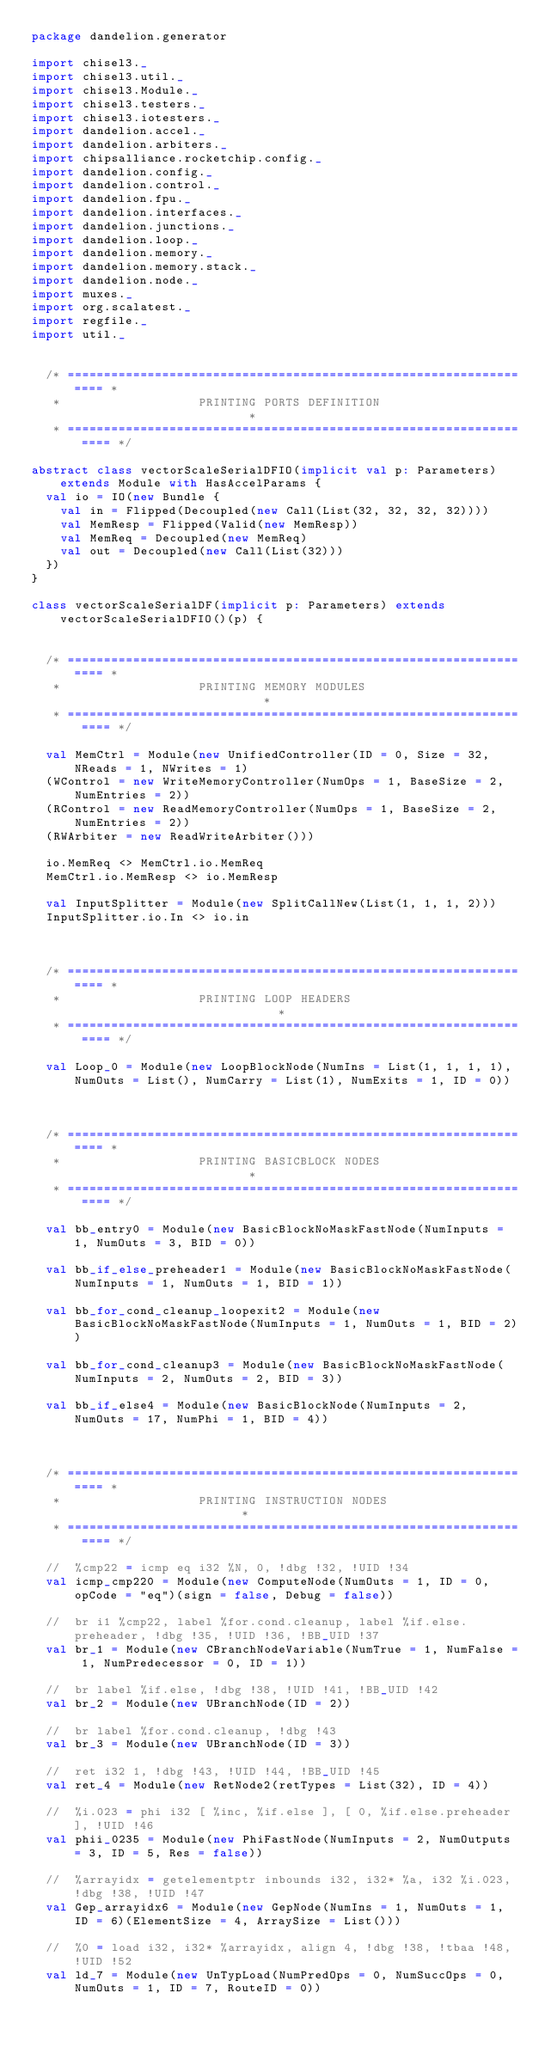<code> <loc_0><loc_0><loc_500><loc_500><_Scala_>package dandelion.generator

import chisel3._
import chisel3.util._
import chisel3.Module._
import chisel3.testers._
import chisel3.iotesters._
import dandelion.accel._
import dandelion.arbiters._
import chipsalliance.rocketchip.config._
import dandelion.config._
import dandelion.control._
import dandelion.fpu._
import dandelion.interfaces._
import dandelion.junctions._
import dandelion.loop._
import dandelion.memory._
import dandelion.memory.stack._
import dandelion.node._
import muxes._
import org.scalatest._
import regfile._
import util._


  /* ================================================================== *
   *                   PRINTING PORTS DEFINITION                        *
   * ================================================================== */

abstract class vectorScaleSerialDFIO(implicit val p: Parameters) extends Module with HasAccelParams {
  val io = IO(new Bundle {
    val in = Flipped(Decoupled(new Call(List(32, 32, 32, 32))))
    val MemResp = Flipped(Valid(new MemResp))
    val MemReq = Decoupled(new MemReq)
    val out = Decoupled(new Call(List(32)))
  })
}

class vectorScaleSerialDF(implicit p: Parameters) extends vectorScaleSerialDFIO()(p) {


  /* ================================================================== *
   *                   PRINTING MEMORY MODULES                          *
   * ================================================================== */

  val MemCtrl = Module(new UnifiedController(ID = 0, Size = 32, NReads = 1, NWrites = 1)
  (WControl = new WriteMemoryController(NumOps = 1, BaseSize = 2, NumEntries = 2))
  (RControl = new ReadMemoryController(NumOps = 1, BaseSize = 2, NumEntries = 2))
  (RWArbiter = new ReadWriteArbiter()))

  io.MemReq <> MemCtrl.io.MemReq
  MemCtrl.io.MemResp <> io.MemResp

  val InputSplitter = Module(new SplitCallNew(List(1, 1, 1, 2)))
  InputSplitter.io.In <> io.in



  /* ================================================================== *
   *                   PRINTING LOOP HEADERS                            *
   * ================================================================== */

  val Loop_0 = Module(new LoopBlockNode(NumIns = List(1, 1, 1, 1), NumOuts = List(), NumCarry = List(1), NumExits = 1, ID = 0))



  /* ================================================================== *
   *                   PRINTING BASICBLOCK NODES                        *
   * ================================================================== */

  val bb_entry0 = Module(new BasicBlockNoMaskFastNode(NumInputs = 1, NumOuts = 3, BID = 0))

  val bb_if_else_preheader1 = Module(new BasicBlockNoMaskFastNode(NumInputs = 1, NumOuts = 1, BID = 1))

  val bb_for_cond_cleanup_loopexit2 = Module(new BasicBlockNoMaskFastNode(NumInputs = 1, NumOuts = 1, BID = 2))

  val bb_for_cond_cleanup3 = Module(new BasicBlockNoMaskFastNode(NumInputs = 2, NumOuts = 2, BID = 3))

  val bb_if_else4 = Module(new BasicBlockNode(NumInputs = 2, NumOuts = 17, NumPhi = 1, BID = 4))



  /* ================================================================== *
   *                   PRINTING INSTRUCTION NODES                       *
   * ================================================================== */

  //  %cmp22 = icmp eq i32 %N, 0, !dbg !32, !UID !34
  val icmp_cmp220 = Module(new ComputeNode(NumOuts = 1, ID = 0, opCode = "eq")(sign = false, Debug = false))

  //  br i1 %cmp22, label %for.cond.cleanup, label %if.else.preheader, !dbg !35, !UID !36, !BB_UID !37
  val br_1 = Module(new CBranchNodeVariable(NumTrue = 1, NumFalse = 1, NumPredecessor = 0, ID = 1))

  //  br label %if.else, !dbg !38, !UID !41, !BB_UID !42
  val br_2 = Module(new UBranchNode(ID = 2))

  //  br label %for.cond.cleanup, !dbg !43
  val br_3 = Module(new UBranchNode(ID = 3))

  //  ret i32 1, !dbg !43, !UID !44, !BB_UID !45
  val ret_4 = Module(new RetNode2(retTypes = List(32), ID = 4))

  //  %i.023 = phi i32 [ %inc, %if.else ], [ 0, %if.else.preheader ], !UID !46
  val phii_0235 = Module(new PhiFastNode(NumInputs = 2, NumOutputs = 3, ID = 5, Res = false))

  //  %arrayidx = getelementptr inbounds i32, i32* %a, i32 %i.023, !dbg !38, !UID !47
  val Gep_arrayidx6 = Module(new GepNode(NumIns = 1, NumOuts = 1, ID = 6)(ElementSize = 4, ArraySize = List()))

  //  %0 = load i32, i32* %arrayidx, align 4, !dbg !38, !tbaa !48, !UID !52
  val ld_7 = Module(new UnTypLoad(NumPredOps = 0, NumSuccOps = 0, NumOuts = 1, ID = 7, RouteID = 0))
</code> 